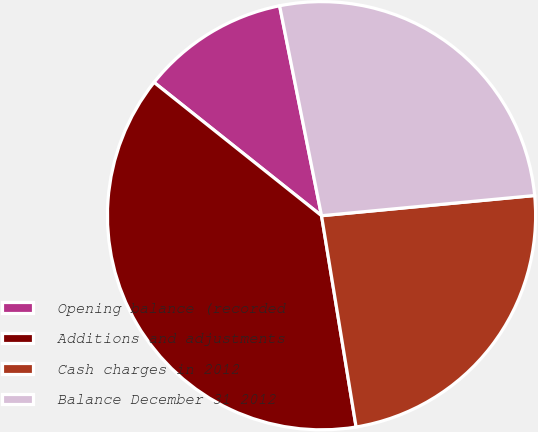<chart> <loc_0><loc_0><loc_500><loc_500><pie_chart><fcel>Opening balance (recorded<fcel>Additions and adjustments<fcel>Cash charges in 2012<fcel>Balance December 31 2012<nl><fcel>11.16%<fcel>38.28%<fcel>23.92%<fcel>26.63%<nl></chart> 